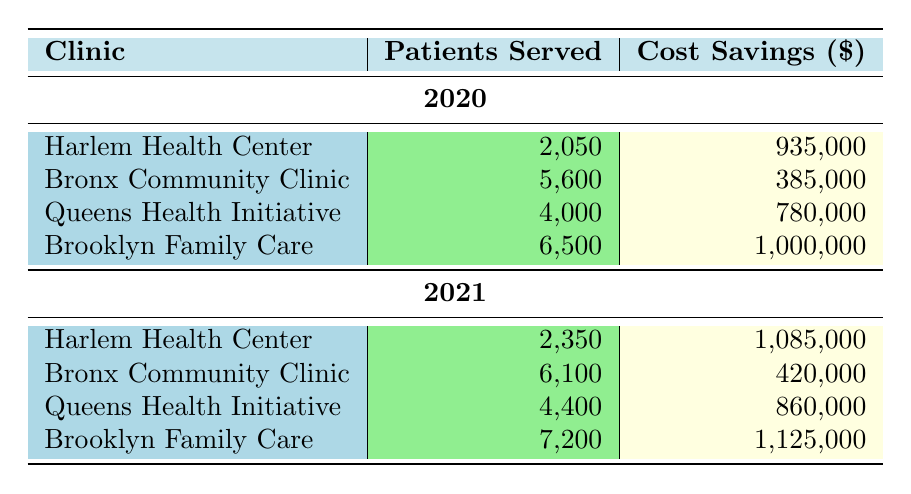What was the total cost savings for the Brooklyn Family Care in 2020? To find the total cost savings for Brooklyn Family Care in 2020, look at the entry for that clinic and year. The cost savings for the Flu Vaccine is 250,000, and for HIV Screening, it's 750,000. Adding these together gives 250,000 + 750,000 = 1,000,000.
Answer: 1,000,000 How many patients were served at the Harlem Health Center in 2021? The table shows two services provided by Harlem Health Center in 2021: Mammogram and Colonoscopy. For Mammogram, 1,400 patients were served, and for Colonoscopy, 950 patients were served. Adding these gives 1,400 + 950 = 2,350.
Answer: 2,350 Did the Queens Health Initiative see an increase in cost savings from 2020 to 2021? In 2020, the total cost savings for Queens Health Initiative is 780,000, and in 2021, it is 860,000. Since 860,000 is greater than 780,000, it indicates an increase.
Answer: Yes What was the average number of patients served by the Bronx Community Clinic in both years? The Bronx Community Clinic served 5,600 patients in total: 5,600 in 2020 (2,100 for Pap Smear and 3,500 for Blood Pressure Screening) and 6,100 in 2021 (2,300 for Pap Smear and 3,800 for Blood Pressure Screening). Adding the two totals gives 5,600 + 6,100 = 11,700. Dividing by 2 gives an average of 11,700 / 2 = 5,850.
Answer: 5,850 Which clinic had the highest cost savings in 2021? From the table, analyzing the total cost savings for each clinic in 2021: Harlem Health Center is 1,085,000, Bronx Community Clinic is 420,000, Queens Health Initiative is 860,000, and Brooklyn Family Care is 1,125,000. The highest figure among these is 1,125,000, which belongs to Brooklyn Family Care.
Answer: Brooklyn Family Care 